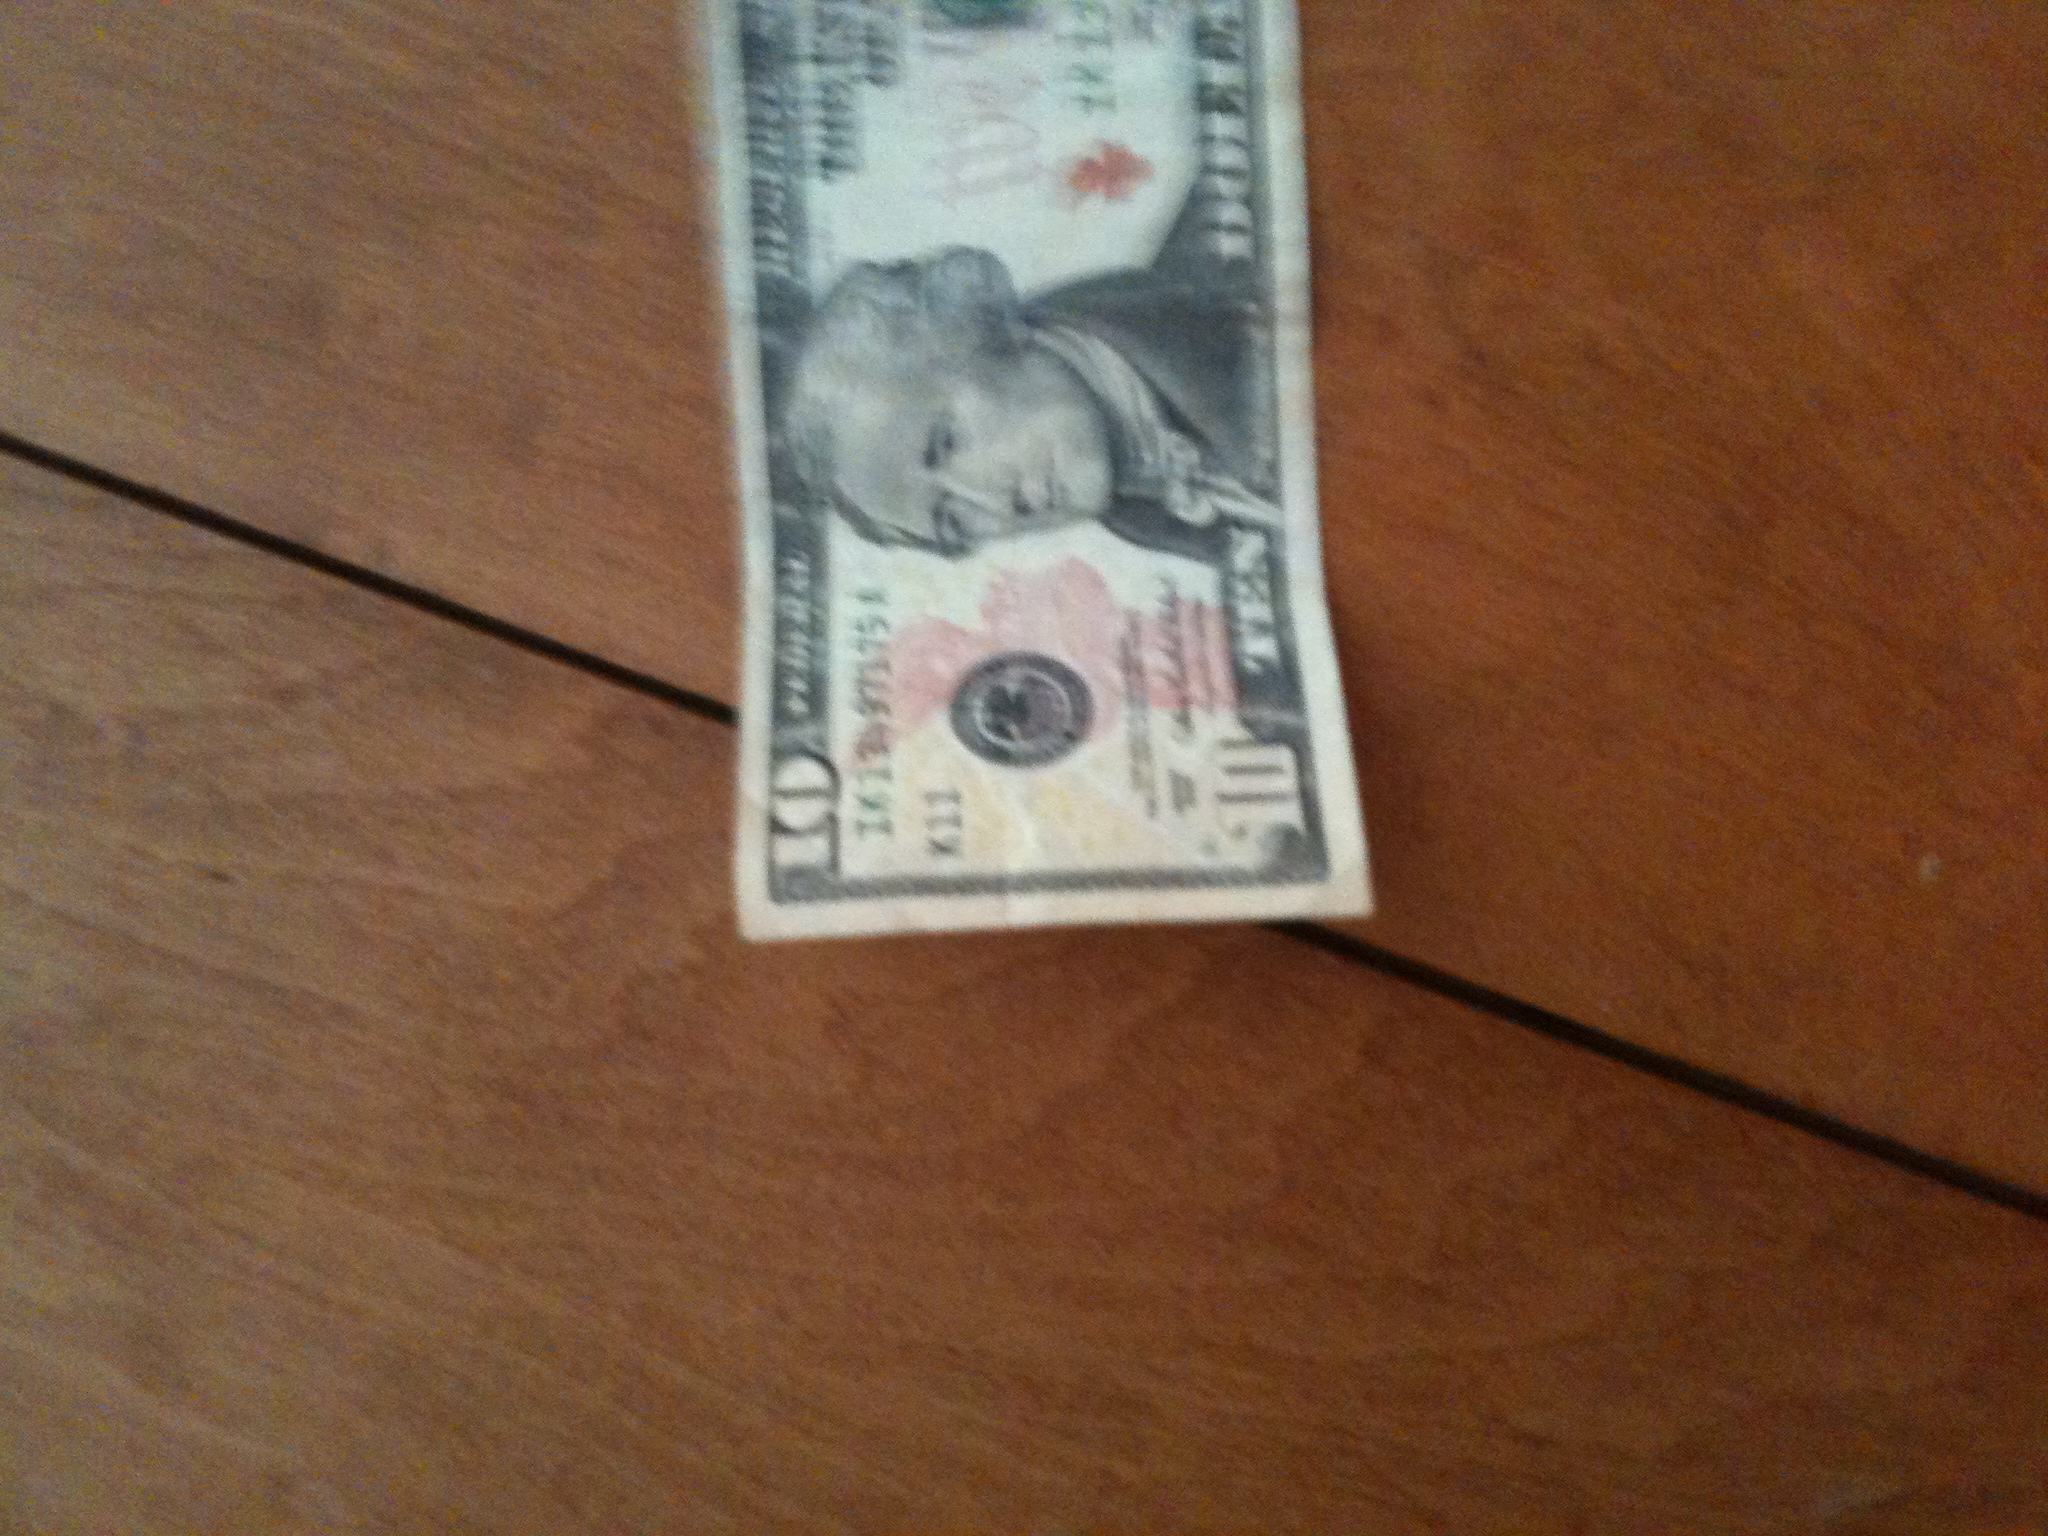What would be a realistic usage of this bill in a daily scenario? In a realistic scenario, someone might use this 10-dollar bill to buy a quick meal, such as a sandwich and a drink, at a local deli or cafe. With inflation and prices varying by location, this bill might cover the cost of a couple of small items or a modest lunch, reflecting the everyday utility of cash in small transactions. Can you describe a detailed scenario where this bill plays a significant role in someone's life? Certainly! Imagine a young artist trying to make a name for themselves in a bustling city. One afternoon, they find this 10-dollar bill on the street. With only a few dollars in their wallet and a grumbling stomach, they decide to spend it at a small café, known for its welcoming atmosphere. In the café, the artist strikes up a conversation with another patron, who turns out to be a well-known art dealer. The dealer is impressed by the artist's passion and offers to visit their studio. This chance encounter, sparked by the decision to spend a found 10-dollar bill, becomes the turning point in the artist's career. The dealer helps the artist get their first gallery show, leading to critical acclaim and a successful career. Thus, the humble 10-dollar bill becomes a catalyst for changing someone's life trajectory. 